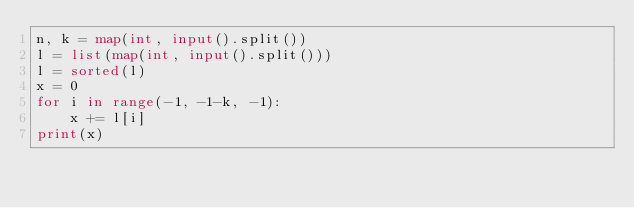<code> <loc_0><loc_0><loc_500><loc_500><_Python_>n, k = map(int, input().split())
l = list(map(int, input().split()))
l = sorted(l)
x = 0
for i in range(-1, -1-k, -1):
    x += l[i]
print(x)</code> 